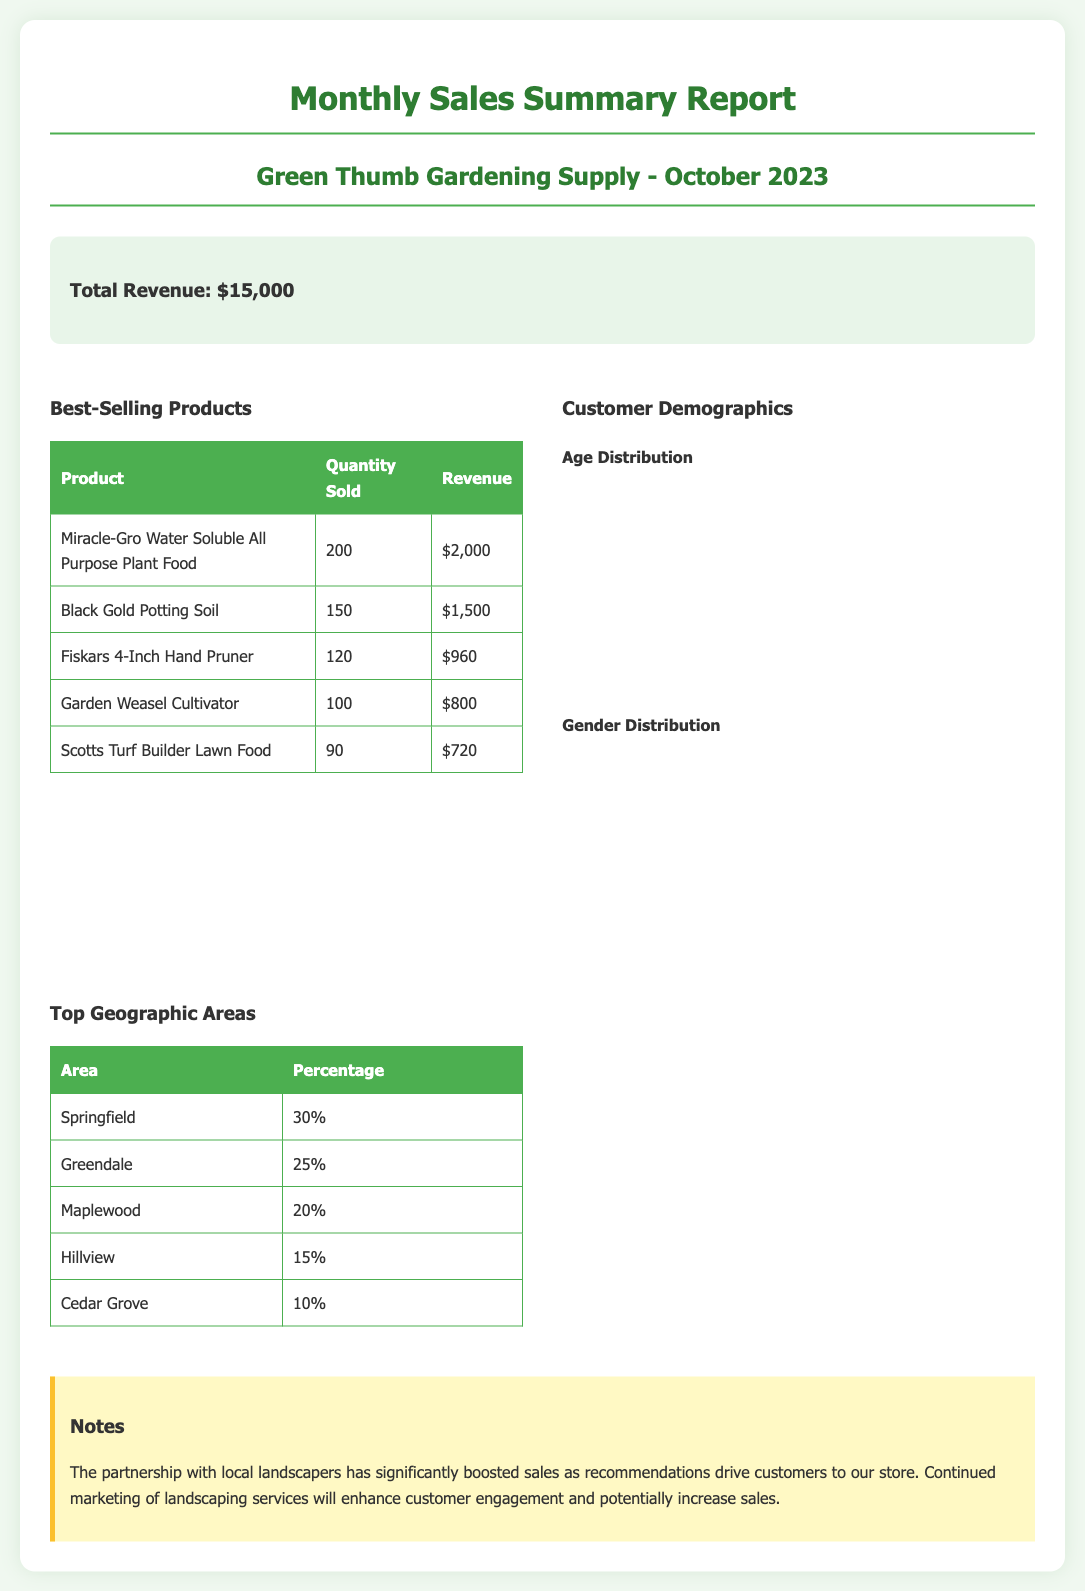What is the total revenue? The total revenue is stated at the top of the summary section.
Answer: $15,000 What is the best-selling product? The first product listed in the best-selling products table is identified.
Answer: Miracle-Gro Water Soluble All Purpose Plant Food How many units of Black Gold Potting Soil were sold? The quantity sold of Black Gold Potting Soil can be found in the best-selling products table.
Answer: 150 What percentage of sales came from Springfield? The percentage listed for Springfield is in the top geographic areas table.
Answer: 30% What age group has the highest representation? The age group with the largest data segment in the pie chart indicates this information.
Answer: 25-34 What is the percentage of female customers? The female percentage is shown in the gender distribution doughnut chart.
Answer: 60 How many total geographic areas are listed? The number of rows in the top geographic areas table indicates the total areas.
Answer: 5 What revenue did the Fiskars 4-Inch Hand Pruner generate? The revenue for the Fiskars 4-Inch Hand Pruner is specified in the best-selling products table.
Answer: $960 Which customer demographic chart displays gender distribution? The document contains two demographic charts and identifies which one represents gender.
Answer: Gender Distribution 